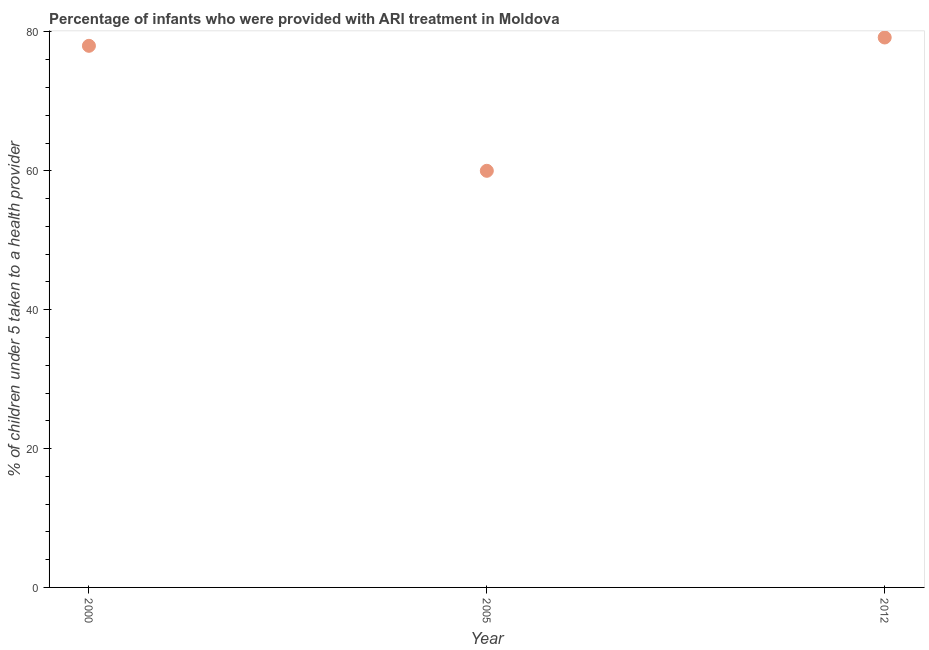Across all years, what is the maximum percentage of children who were provided with ari treatment?
Give a very brief answer. 79.2. What is the sum of the percentage of children who were provided with ari treatment?
Your answer should be very brief. 217.2. What is the difference between the percentage of children who were provided with ari treatment in 2005 and 2012?
Your response must be concise. -19.2. What is the average percentage of children who were provided with ari treatment per year?
Give a very brief answer. 72.4. What is the median percentage of children who were provided with ari treatment?
Your answer should be compact. 78. Do a majority of the years between 2012 and 2005 (inclusive) have percentage of children who were provided with ari treatment greater than 12 %?
Keep it short and to the point. No. What is the ratio of the percentage of children who were provided with ari treatment in 2005 to that in 2012?
Your response must be concise. 0.76. What is the difference between the highest and the second highest percentage of children who were provided with ari treatment?
Provide a succinct answer. 1.2. Is the sum of the percentage of children who were provided with ari treatment in 2000 and 2005 greater than the maximum percentage of children who were provided with ari treatment across all years?
Provide a succinct answer. Yes. What is the difference between the highest and the lowest percentage of children who were provided with ari treatment?
Ensure brevity in your answer.  19.2. In how many years, is the percentage of children who were provided with ari treatment greater than the average percentage of children who were provided with ari treatment taken over all years?
Your answer should be compact. 2. How many dotlines are there?
Make the answer very short. 1. How many years are there in the graph?
Your response must be concise. 3. Does the graph contain any zero values?
Offer a very short reply. No. Does the graph contain grids?
Make the answer very short. No. What is the title of the graph?
Keep it short and to the point. Percentage of infants who were provided with ARI treatment in Moldova. What is the label or title of the X-axis?
Keep it short and to the point. Year. What is the label or title of the Y-axis?
Offer a very short reply. % of children under 5 taken to a health provider. What is the % of children under 5 taken to a health provider in 2000?
Offer a terse response. 78. What is the % of children under 5 taken to a health provider in 2012?
Your answer should be very brief. 79.2. What is the difference between the % of children under 5 taken to a health provider in 2000 and 2005?
Provide a short and direct response. 18. What is the difference between the % of children under 5 taken to a health provider in 2005 and 2012?
Provide a short and direct response. -19.2. What is the ratio of the % of children under 5 taken to a health provider in 2000 to that in 2012?
Your answer should be very brief. 0.98. What is the ratio of the % of children under 5 taken to a health provider in 2005 to that in 2012?
Your answer should be very brief. 0.76. 